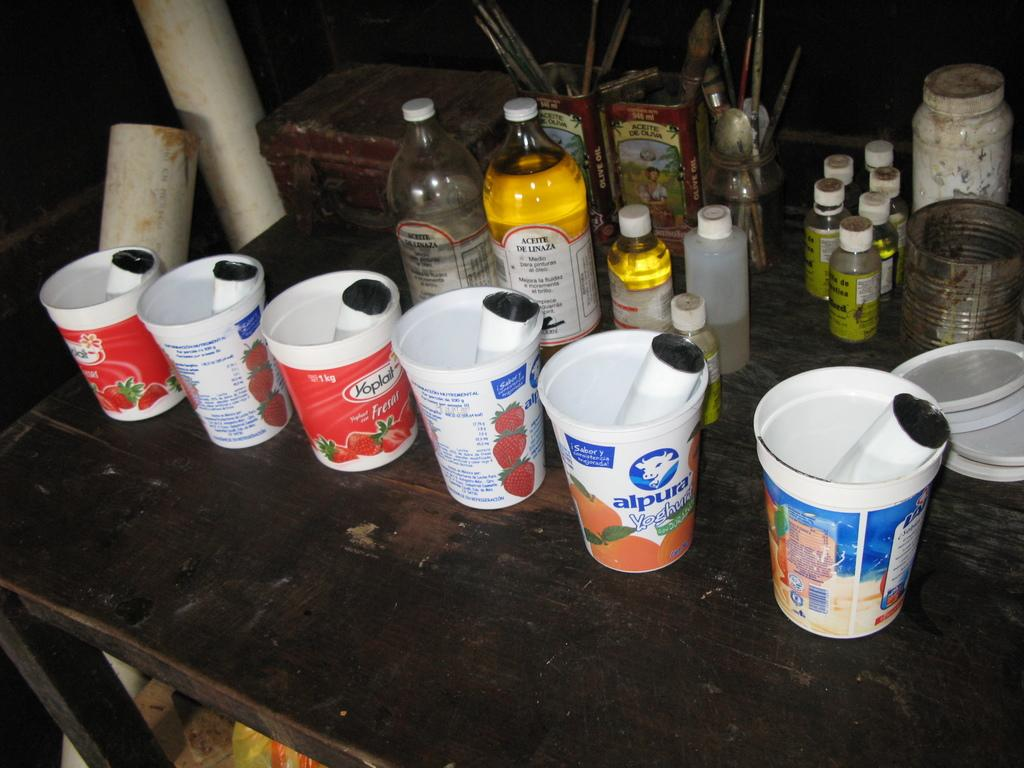<image>
Relay a brief, clear account of the picture shown. several yogurt cups, including yoplait are being used to hold things on the table 